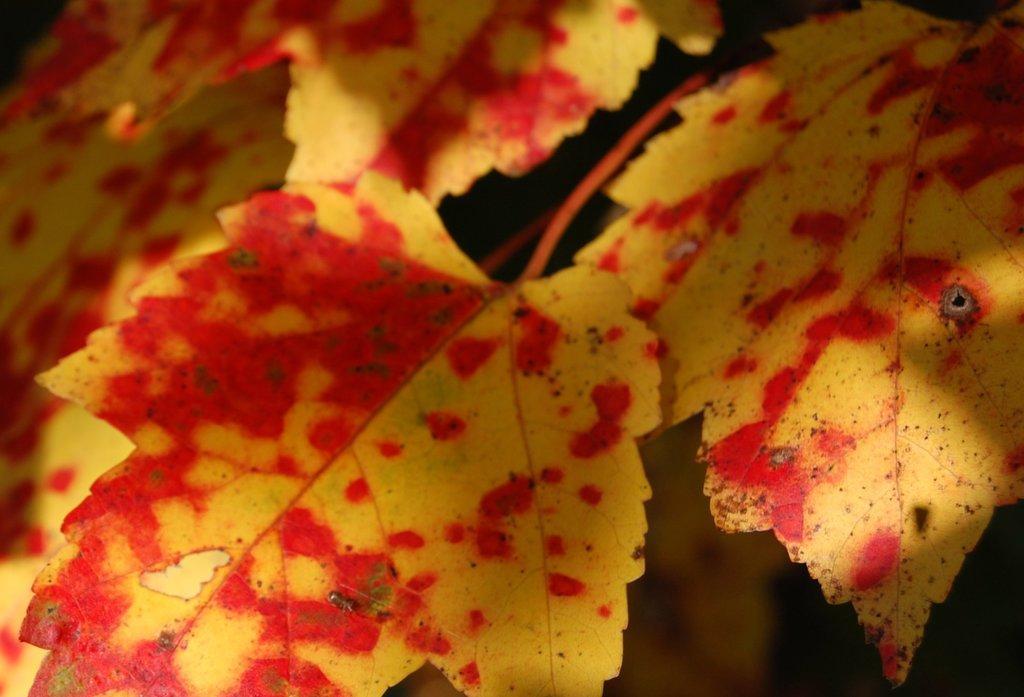Describe this image in one or two sentences. In this image I can see few leaves in brown and red color. Background is in black color. 